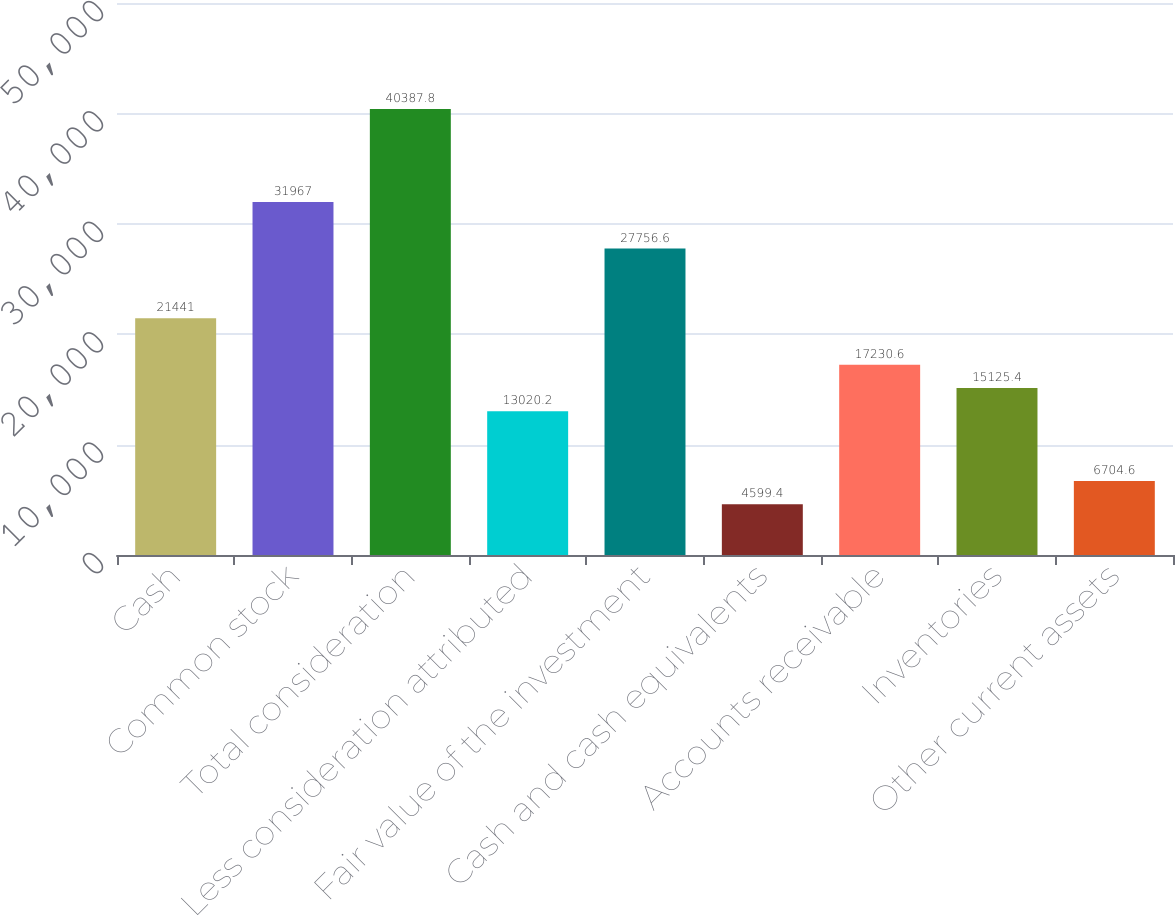<chart> <loc_0><loc_0><loc_500><loc_500><bar_chart><fcel>Cash<fcel>Common stock<fcel>Total consideration<fcel>Less consideration attributed<fcel>Fair value of the investment<fcel>Cash and cash equivalents<fcel>Accounts receivable<fcel>Inventories<fcel>Other current assets<nl><fcel>21441<fcel>31967<fcel>40387.8<fcel>13020.2<fcel>27756.6<fcel>4599.4<fcel>17230.6<fcel>15125.4<fcel>6704.6<nl></chart> 